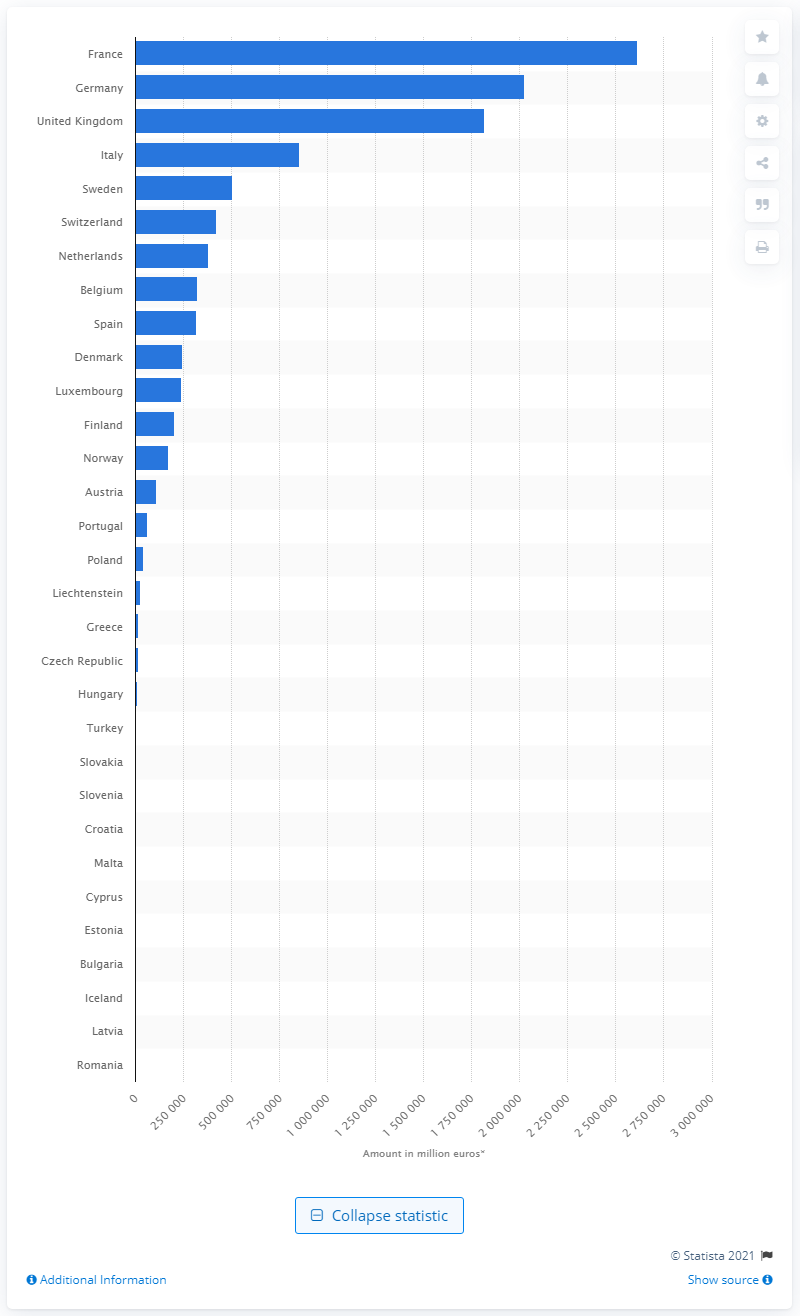Give some essential details in this illustration. In 2019, the portfolio value of insurers operating in France was approximately 26,162,010. 